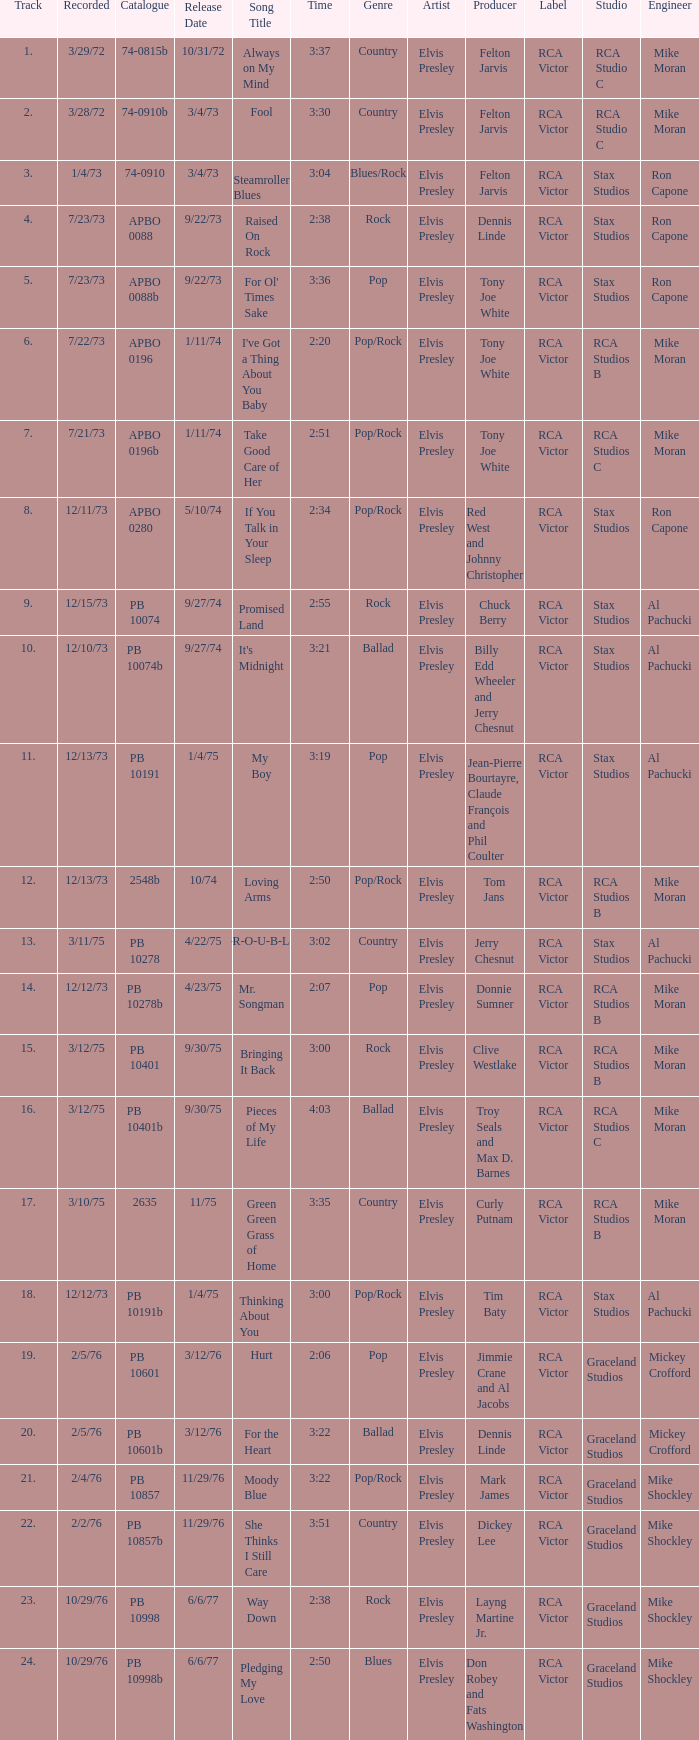Tell me the release date record on 10/29/76 and a time on 2:50 6/6/77. Give me the full table as a dictionary. {'header': ['Track', 'Recorded', 'Catalogue', 'Release Date', 'Song Title', 'Time', 'Genre', 'Artist', 'Producer', 'Label', 'Studio', 'Engineer'], 'rows': [['1.', '3/29/72', '74-0815b', '10/31/72', 'Always on My Mind', '3:37', 'Country', 'Elvis Presley', 'Felton Jarvis', 'RCA Victor', 'RCA Studio C', 'Mike Moran'], ['2.', '3/28/72', '74-0910b', '3/4/73', 'Fool', '3:30', 'Country', 'Elvis Presley', 'Felton Jarvis', 'RCA Victor', 'RCA Studio C', 'Mike Moran'], ['3.', '1/4/73', '74-0910', '3/4/73', 'Steamroller Blues', '3:04', 'Blues/Rock', 'Elvis Presley', 'Felton Jarvis', 'RCA Victor', 'Stax Studios', 'Ron Capone'], ['4.', '7/23/73', 'APBO 0088', '9/22/73', 'Raised On Rock', '2:38', 'Rock', 'Elvis Presley', 'Dennis Linde', 'RCA Victor', 'Stax Studios', 'Ron Capone'], ['5.', '7/23/73', 'APBO 0088b', '9/22/73', "For Ol' Times Sake", '3:36', 'Pop', 'Elvis Presley', 'Tony Joe White', 'RCA Victor', 'Stax Studios', 'Ron Capone'], ['6.', '7/22/73', 'APBO 0196', '1/11/74', "I've Got a Thing About You Baby", '2:20', 'Pop/Rock', 'Elvis Presley', 'Tony Joe White', 'RCA Victor', 'RCA Studios B', 'Mike Moran'], ['7.', '7/21/73', 'APBO 0196b', '1/11/74', 'Take Good Care of Her', '2:51', 'Pop/Rock', 'Elvis Presley', 'Tony Joe White', 'RCA Victor', 'RCA Studios C', 'Mike Moran'], ['8.', '12/11/73', 'APBO 0280', '5/10/74', 'If You Talk in Your Sleep', '2:34', 'Pop/Rock', 'Elvis Presley', 'Red West and Johnny Christopher', 'RCA Victor', 'Stax Studios', 'Ron Capone'], ['9.', '12/15/73', 'PB 10074', '9/27/74', 'Promised Land', '2:55', 'Rock', 'Elvis Presley', 'Chuck Berry', 'RCA Victor', 'Stax Studios', 'Al Pachucki'], ['10.', '12/10/73', 'PB 10074b', '9/27/74', "It's Midnight", '3:21', 'Ballad', 'Elvis Presley', 'Billy Edd Wheeler and Jerry Chesnut', 'RCA Victor', 'Stax Studios', 'Al Pachucki'], ['11.', '12/13/73', 'PB 10191', '1/4/75', 'My Boy', '3:19', 'Pop', 'Elvis Presley', 'Jean-Pierre Bourtayre, Claude François and Phil Coulter', 'RCA Victor', 'Stax Studios', 'Al Pachucki'], ['12.', '12/13/73', '2548b', '10/74', 'Loving Arms', '2:50', 'Pop/Rock', 'Elvis Presley', 'Tom Jans', 'RCA Victor', 'RCA Studios B', 'Mike Moran'], ['13.', '3/11/75', 'PB 10278', '4/22/75', 'T-R-O-U-B-L-E', '3:02', 'Country', 'Elvis Presley', 'Jerry Chesnut', 'RCA Victor', 'Stax Studios', 'Al Pachucki'], ['14.', '12/12/73', 'PB 10278b', '4/23/75', 'Mr. Songman', '2:07', 'Pop', 'Elvis Presley', 'Donnie Sumner', 'RCA Victor', 'RCA Studios B', 'Mike Moran'], ['15.', '3/12/75', 'PB 10401', '9/30/75', 'Bringing It Back', '3:00', 'Rock', 'Elvis Presley', 'Clive Westlake', 'RCA Victor', 'RCA Studios B', 'Mike Moran'], ['16.', '3/12/75', 'PB 10401b', '9/30/75', 'Pieces of My Life', '4:03', 'Ballad', 'Elvis Presley', 'Troy Seals and Max D. Barnes', 'RCA Victor', 'RCA Studios C', 'Mike Moran'], ['17.', '3/10/75', '2635', '11/75', 'Green Green Grass of Home', '3:35', 'Country', 'Elvis Presley', 'Curly Putnam', 'RCA Victor', 'RCA Studios B', 'Mike Moran'], ['18.', '12/12/73', 'PB 10191b', '1/4/75', 'Thinking About You', '3:00', 'Pop/Rock', 'Elvis Presley', 'Tim Baty', 'RCA Victor', 'Stax Studios', 'Al Pachucki'], ['19.', '2/5/76', 'PB 10601', '3/12/76', 'Hurt', '2:06', 'Pop', 'Elvis Presley', 'Jimmie Crane and Al Jacobs', 'RCA Victor', 'Graceland Studios', 'Mickey Crofford'], ['20.', '2/5/76', 'PB 10601b', '3/12/76', 'For the Heart', '3:22', 'Ballad', 'Elvis Presley', 'Dennis Linde', 'RCA Victor', 'Graceland Studios', 'Mickey Crofford'], ['21.', '2/4/76', 'PB 10857', '11/29/76', 'Moody Blue', '3:22', 'Pop/Rock', 'Elvis Presley', 'Mark James', 'RCA Victor', 'Graceland Studios', 'Mike Shockley'], ['22.', '2/2/76', 'PB 10857b', '11/29/76', 'She Thinks I Still Care', '3:51', 'Country', 'Elvis Presley', 'Dickey Lee', 'RCA Victor', 'Graceland Studios', 'Mike Shockley'], ['23.', '10/29/76', 'PB 10998', '6/6/77', 'Way Down', '2:38', 'Rock', 'Elvis Presley', 'Layng Martine Jr.', 'RCA Victor', 'Graceland Studios', 'Mike Shockley'], ['24.', '10/29/76', 'PB 10998b', '6/6/77', 'Pledging My Love', '2:50', 'Blues', 'Elvis Presley', 'Don Robey and Fats Washington', 'RCA Victor', 'Graceland Studios', 'Mike Shockley']]} 